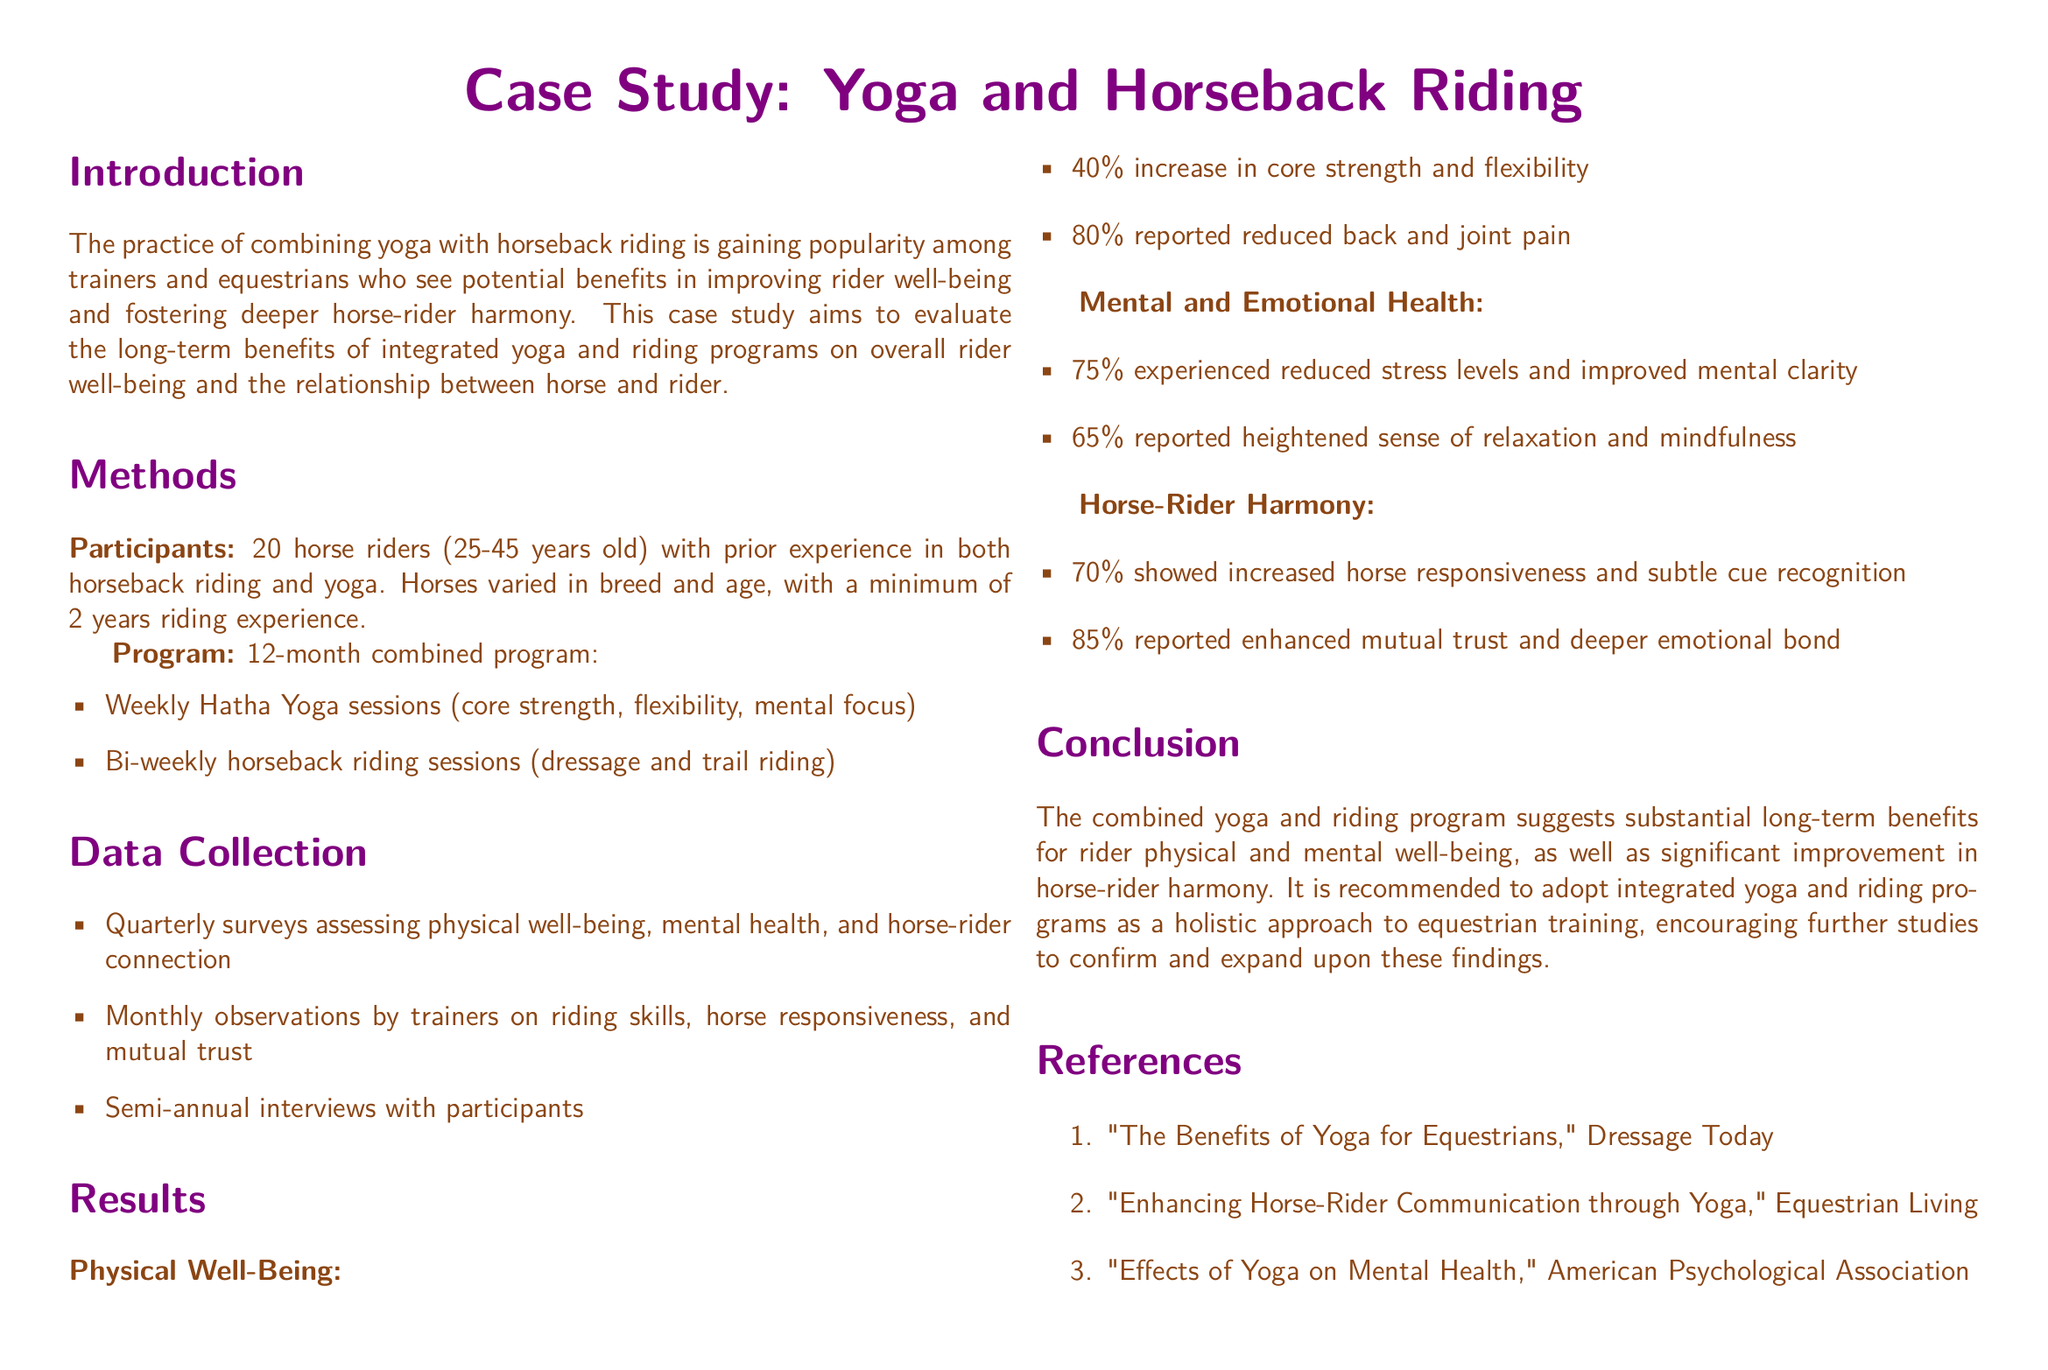what is the age range of participants? The age range of participants is stated as 25-45 years old in the document.
Answer: 25-45 years old how many riders participated in the program? The document specifies that 20 horse riders participated in the study.
Answer: 20 what percentage reported reduced back and joint pain? The results indicate that 80% of participants reported reduced back and joint pain.
Answer: 80% what is the duration of the combined program? The combined program lasted for 12 months according to the methods section.
Answer: 12 months what aspect of mental health improved for 75% of participants? The document states that 75% experienced reduced stress levels and improved mental clarity.
Answer: reduced stress levels what percentage of participants showed increased horse responsiveness? The results section indicates that 70% showed increased horse responsiveness.
Answer: 70% what type of yoga sessions were included in the program? The program included weekly Hatha Yoga sessions focusing on core strength, flexibility, and mental focus.
Answer: Hatha Yoga what was the main focus of the case study? The main focus of the case study is on evaluating the long-term benefits of combined yoga and riding programs on rider well-being and horse-rider harmony.
Answer: rider well-being and horse-rider harmony what kind of riding sessions were included in the program? The program incorporated bi-weekly horseback riding sessions that included dressage and trail riding.
Answer: dressage and trail riding 